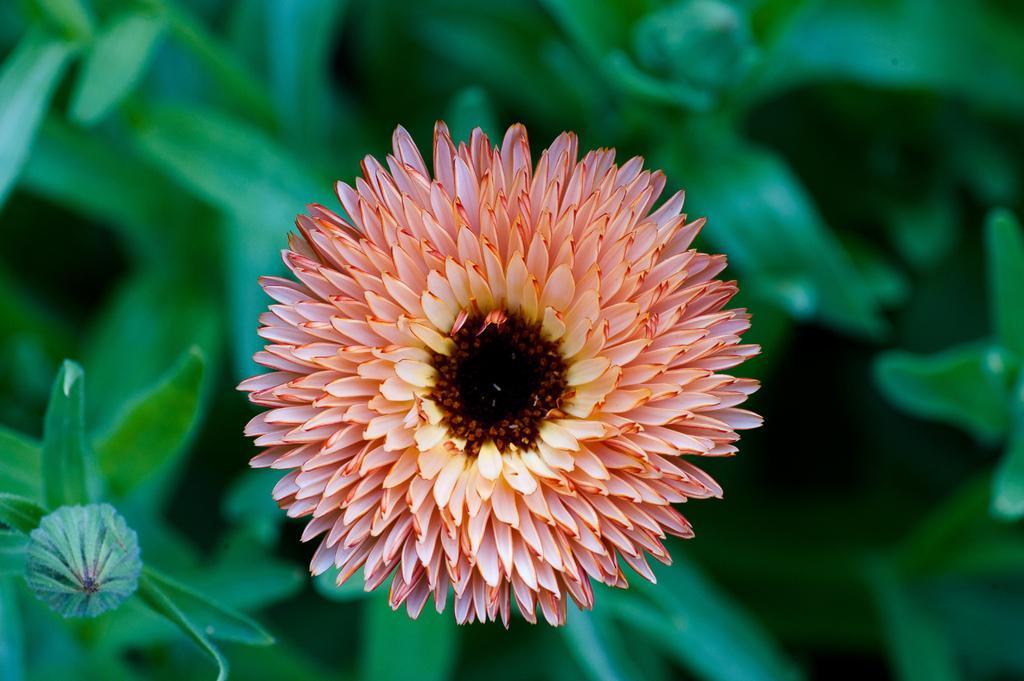How would you summarize this image in a sentence or two? In the image we can see a flower, pale red and pale yellow in color. These are the leaves. 